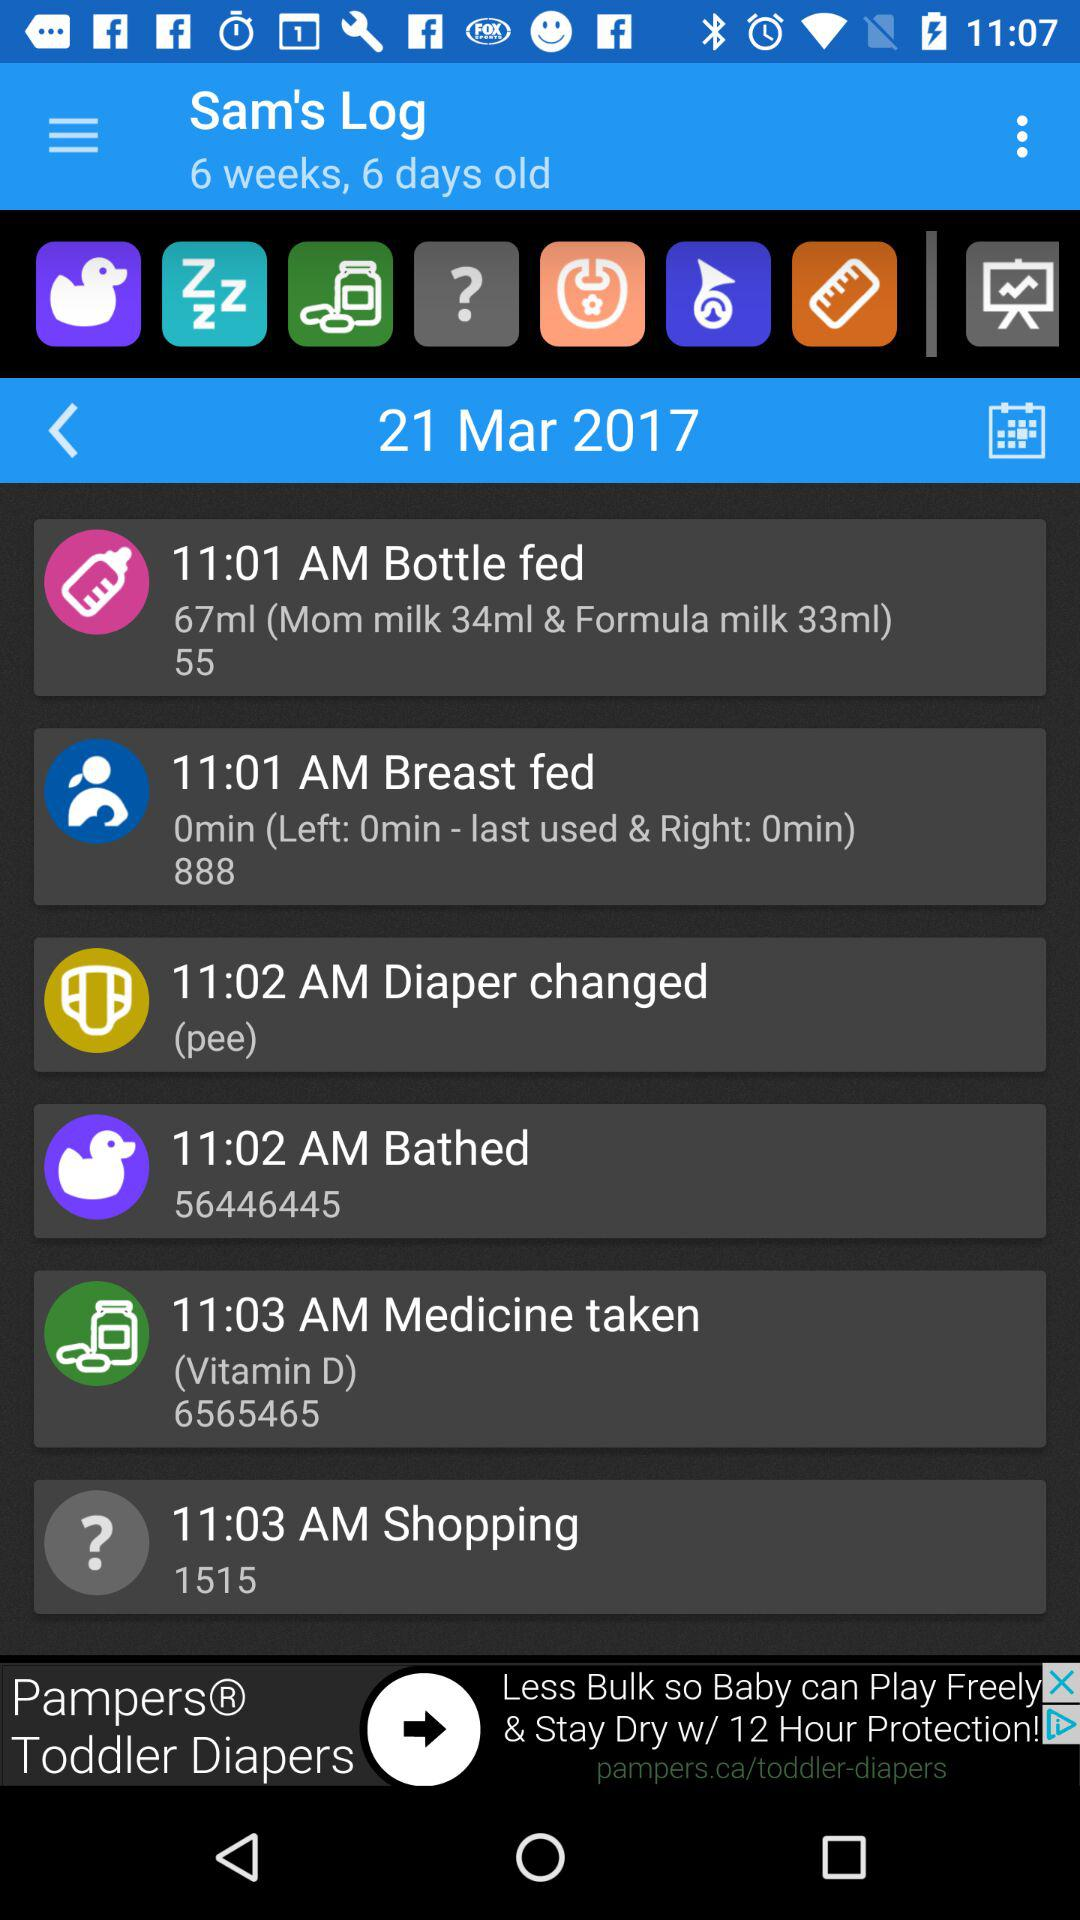What is the time for breastfeeding? The time for breastfeeding is 11:01 a.m. 